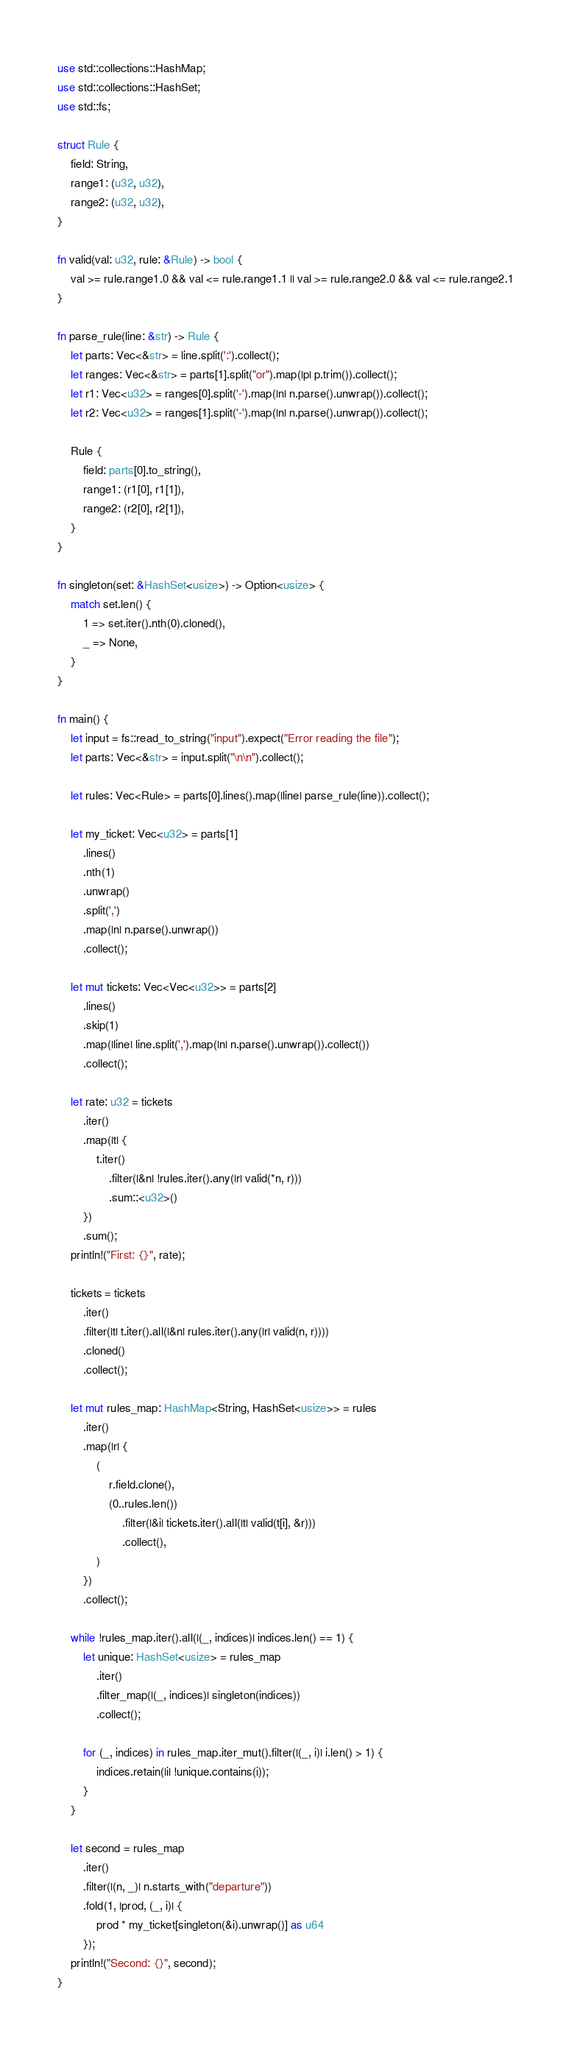Convert code to text. <code><loc_0><loc_0><loc_500><loc_500><_Rust_>use std::collections::HashMap;
use std::collections::HashSet;
use std::fs;

struct Rule {
    field: String,
    range1: (u32, u32),
    range2: (u32, u32),
}

fn valid(val: u32, rule: &Rule) -> bool {
    val >= rule.range1.0 && val <= rule.range1.1 || val >= rule.range2.0 && val <= rule.range2.1
}

fn parse_rule(line: &str) -> Rule {
    let parts: Vec<&str> = line.split(':').collect();
    let ranges: Vec<&str> = parts[1].split("or").map(|p| p.trim()).collect();
    let r1: Vec<u32> = ranges[0].split('-').map(|n| n.parse().unwrap()).collect();
    let r2: Vec<u32> = ranges[1].split('-').map(|n| n.parse().unwrap()).collect();

    Rule {
        field: parts[0].to_string(),
        range1: (r1[0], r1[1]),
        range2: (r2[0], r2[1]),
    }
}

fn singleton(set: &HashSet<usize>) -> Option<usize> {
    match set.len() {
        1 => set.iter().nth(0).cloned(),
        _ => None,
    }
}

fn main() {
    let input = fs::read_to_string("input").expect("Error reading the file");
    let parts: Vec<&str> = input.split("\n\n").collect();

    let rules: Vec<Rule> = parts[0].lines().map(|line| parse_rule(line)).collect();

    let my_ticket: Vec<u32> = parts[1]
        .lines()
        .nth(1)
        .unwrap()
        .split(',')
        .map(|n| n.parse().unwrap())
        .collect();

    let mut tickets: Vec<Vec<u32>> = parts[2]
        .lines()
        .skip(1)
        .map(|line| line.split(',').map(|n| n.parse().unwrap()).collect())
        .collect();

    let rate: u32 = tickets
        .iter()
        .map(|t| {
            t.iter()
                .filter(|&n| !rules.iter().any(|r| valid(*n, r)))
                .sum::<u32>()
        })
        .sum();
    println!("First: {}", rate);

    tickets = tickets
        .iter()
        .filter(|t| t.iter().all(|&n| rules.iter().any(|r| valid(n, r))))
        .cloned()
        .collect();

    let mut rules_map: HashMap<String, HashSet<usize>> = rules
        .iter()
        .map(|r| {
            (
                r.field.clone(),
                (0..rules.len())
                    .filter(|&i| tickets.iter().all(|t| valid(t[i], &r)))
                    .collect(),
            )
        })
        .collect();

    while !rules_map.iter().all(|(_, indices)| indices.len() == 1) {
        let unique: HashSet<usize> = rules_map
            .iter()
            .filter_map(|(_, indices)| singleton(indices))
            .collect();

        for (_, indices) in rules_map.iter_mut().filter(|(_, i)| i.len() > 1) {
            indices.retain(|i| !unique.contains(i));
        }
    }

    let second = rules_map
        .iter()
        .filter(|(n, _)| n.starts_with("departure"))
        .fold(1, |prod, (_, i)| {
            prod * my_ticket[singleton(&i).unwrap()] as u64
        });
    println!("Second: {}", second);
}
</code> 